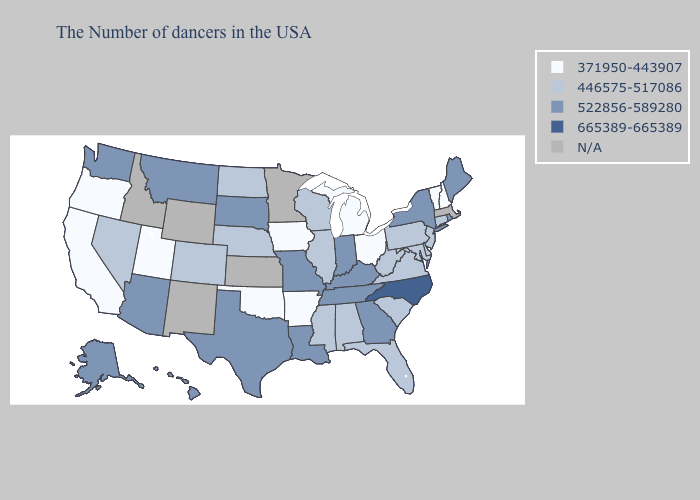What is the value of Colorado?
Give a very brief answer. 446575-517086. Does California have the lowest value in the USA?
Short answer required. Yes. Does Florida have the lowest value in the USA?
Keep it brief. No. Does the map have missing data?
Be succinct. Yes. Name the states that have a value in the range 446575-517086?
Write a very short answer. Connecticut, New Jersey, Delaware, Maryland, Pennsylvania, Virginia, South Carolina, West Virginia, Florida, Alabama, Wisconsin, Illinois, Mississippi, Nebraska, North Dakota, Colorado, Nevada. Does North Carolina have the highest value in the South?
Write a very short answer. Yes. What is the highest value in the South ?
Be succinct. 665389-665389. Name the states that have a value in the range N/A?
Keep it brief. Massachusetts, Minnesota, Kansas, Wyoming, New Mexico, Idaho. Is the legend a continuous bar?
Write a very short answer. No. Name the states that have a value in the range 446575-517086?
Write a very short answer. Connecticut, New Jersey, Delaware, Maryland, Pennsylvania, Virginia, South Carolina, West Virginia, Florida, Alabama, Wisconsin, Illinois, Mississippi, Nebraska, North Dakota, Colorado, Nevada. Among the states that border New York , which have the highest value?
Keep it brief. Connecticut, New Jersey, Pennsylvania. Which states have the lowest value in the USA?
Be succinct. New Hampshire, Vermont, Ohio, Michigan, Arkansas, Iowa, Oklahoma, Utah, California, Oregon. Does the first symbol in the legend represent the smallest category?
Short answer required. Yes. Name the states that have a value in the range 371950-443907?
Be succinct. New Hampshire, Vermont, Ohio, Michigan, Arkansas, Iowa, Oklahoma, Utah, California, Oregon. 